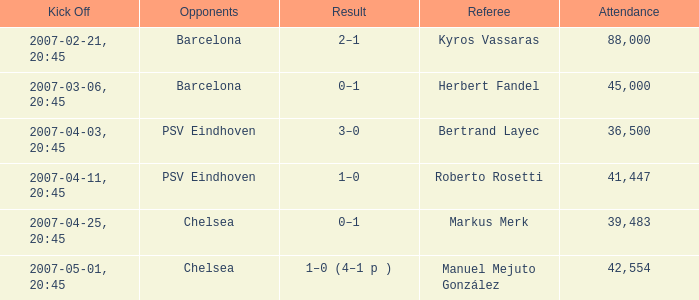Give me the full table as a dictionary. {'header': ['Kick Off', 'Opponents', 'Result', 'Referee', 'Attendance'], 'rows': [['2007-02-21, 20:45', 'Barcelona', '2–1', 'Kyros Vassaras', '88,000'], ['2007-03-06, 20:45', 'Barcelona', '0–1', 'Herbert Fandel', '45,000'], ['2007-04-03, 20:45', 'PSV Eindhoven', '3–0', 'Bertrand Layec', '36,500'], ['2007-04-11, 20:45', 'PSV Eindhoven', '1–0', 'Roberto Rosetti', '41,447'], ['2007-04-25, 20:45', 'Chelsea', '0–1', 'Markus Merk', '39,483'], ['2007-05-01, 20:45', 'Chelsea', '1–0 (4–1 p )', 'Manuel Mejuto González', '42,554']]} WHAT WAS THE SCORE OF THE GAME WITH A 2007-03-06, 20:45 KICKOFF? 0–1. 